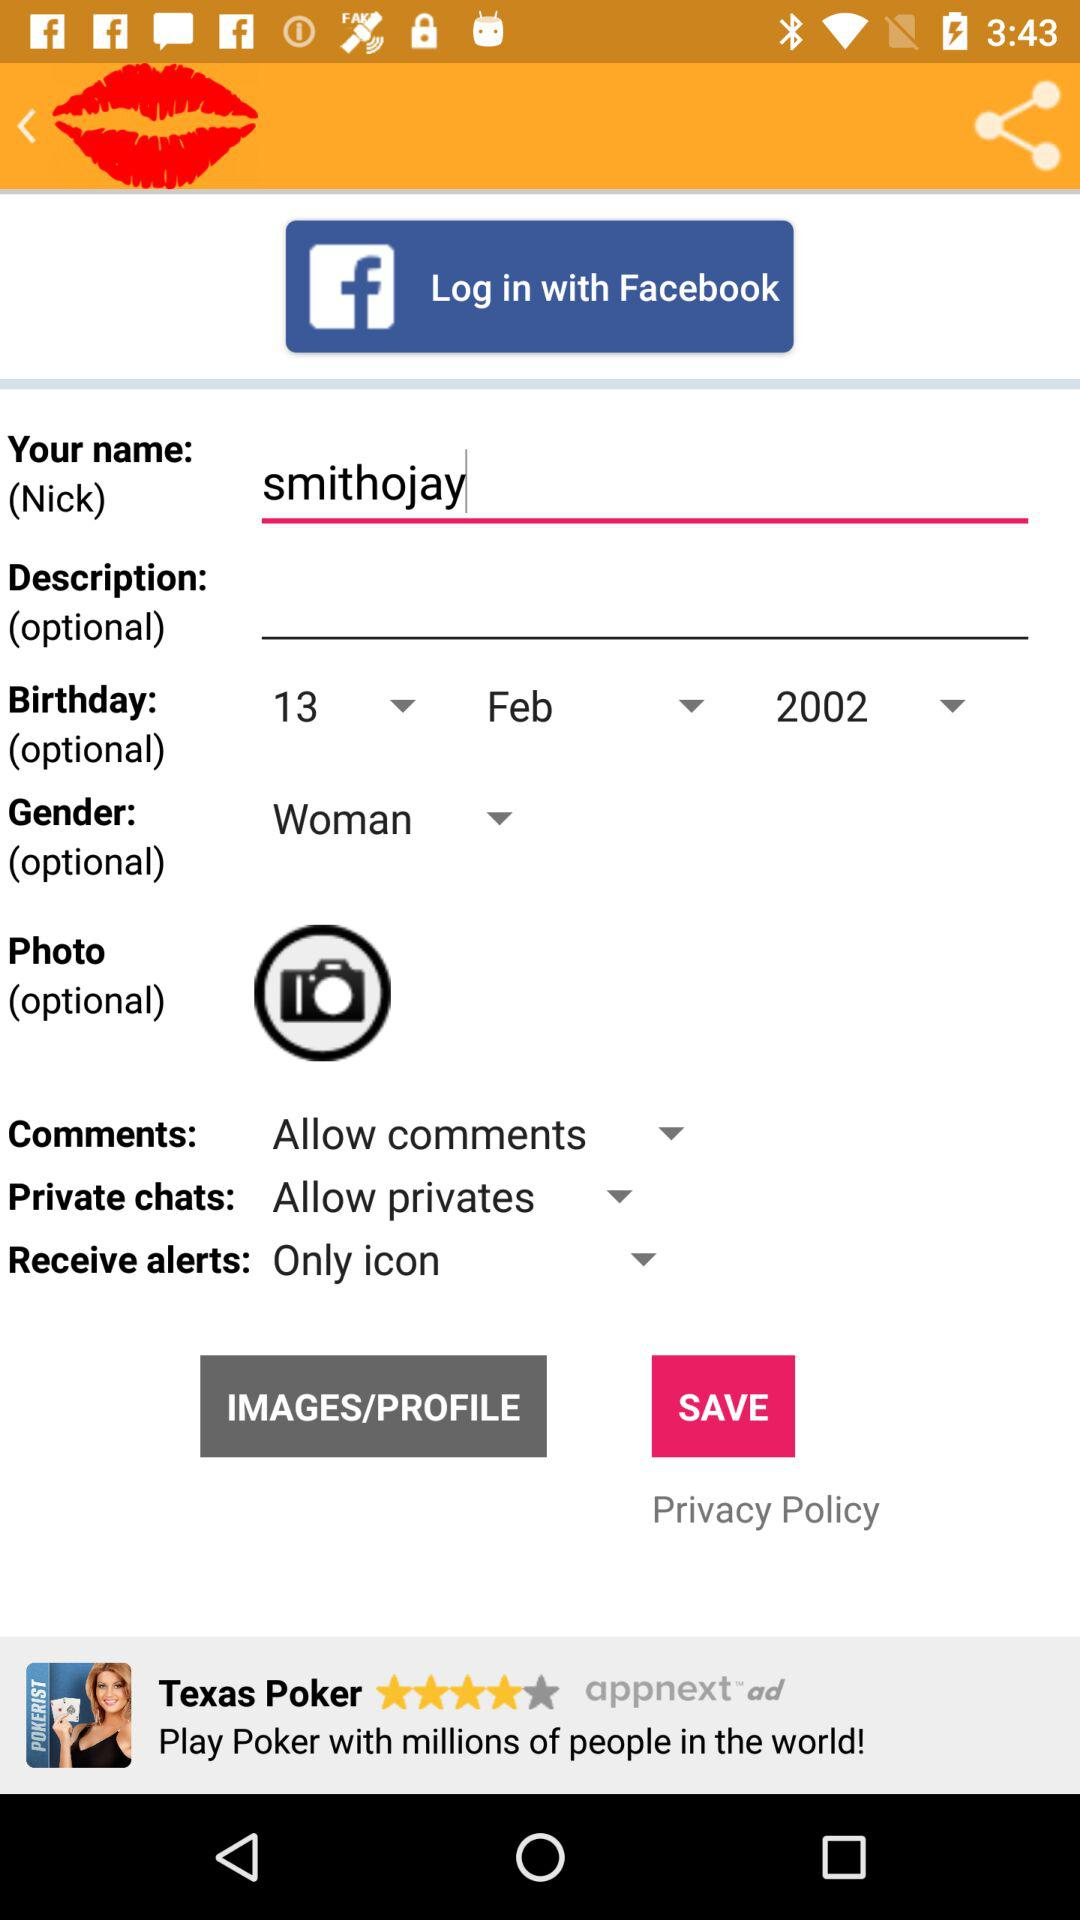What is the setting for the comments? The setting is "Allow comments". 